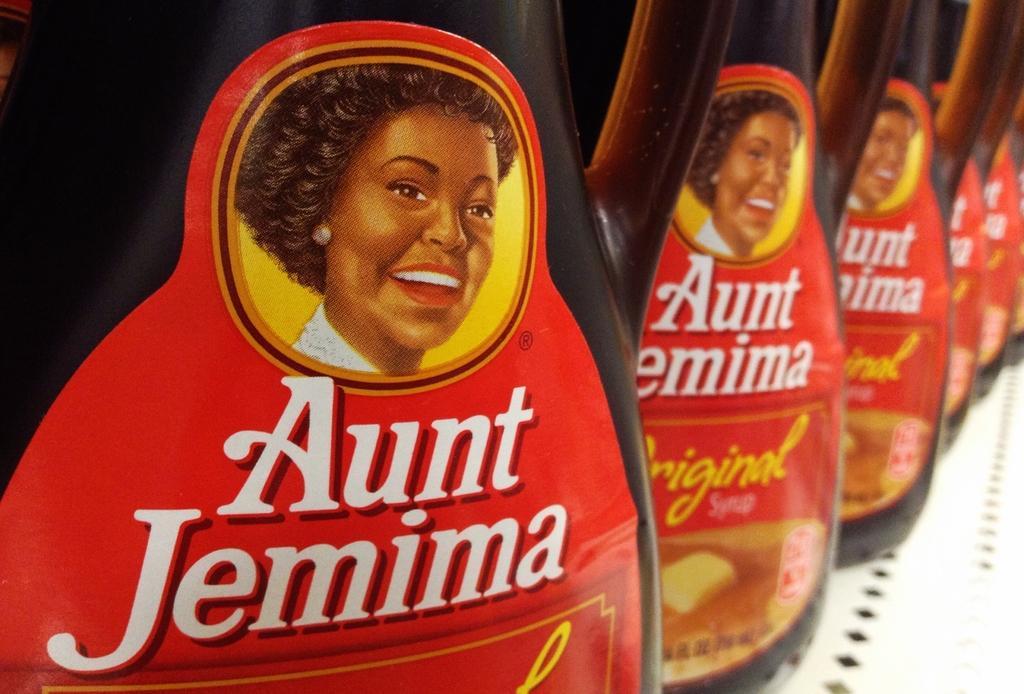Can you describe this image briefly? In the image there are two syrup bottles and there is a picture of a woman on the syrup bottles. 